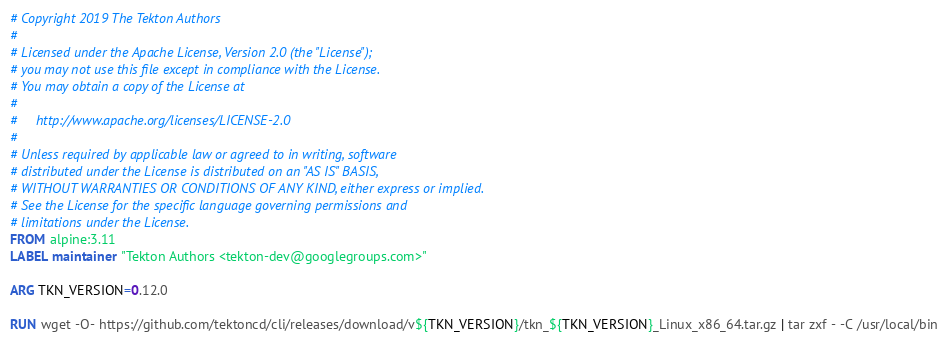Convert code to text. <code><loc_0><loc_0><loc_500><loc_500><_Dockerfile_># Copyright 2019 The Tekton Authors
#
# Licensed under the Apache License, Version 2.0 (the "License");
# you may not use this file except in compliance with the License.
# You may obtain a copy of the License at
#
#     http://www.apache.org/licenses/LICENSE-2.0
#
# Unless required by applicable law or agreed to in writing, software
# distributed under the License is distributed on an "AS IS" BASIS,
# WITHOUT WARRANTIES OR CONDITIONS OF ANY KIND, either express or implied.
# See the License for the specific language governing permissions and
# limitations under the License.
FROM alpine:3.11
LABEL maintainer "Tekton Authors <tekton-dev@googlegroups.com>"

ARG TKN_VERSION=0.12.0

RUN wget -O- https://github.com/tektoncd/cli/releases/download/v${TKN_VERSION}/tkn_${TKN_VERSION}_Linux_x86_64.tar.gz | tar zxf - -C /usr/local/bin
</code> 